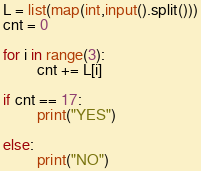<code> <loc_0><loc_0><loc_500><loc_500><_Python_>L = list(map(int,input().split()))
cnt = 0

for i in range(3):
         cnt += L[i]
         
if cnt == 17:
         print("YES")

else:
         print("NO")</code> 